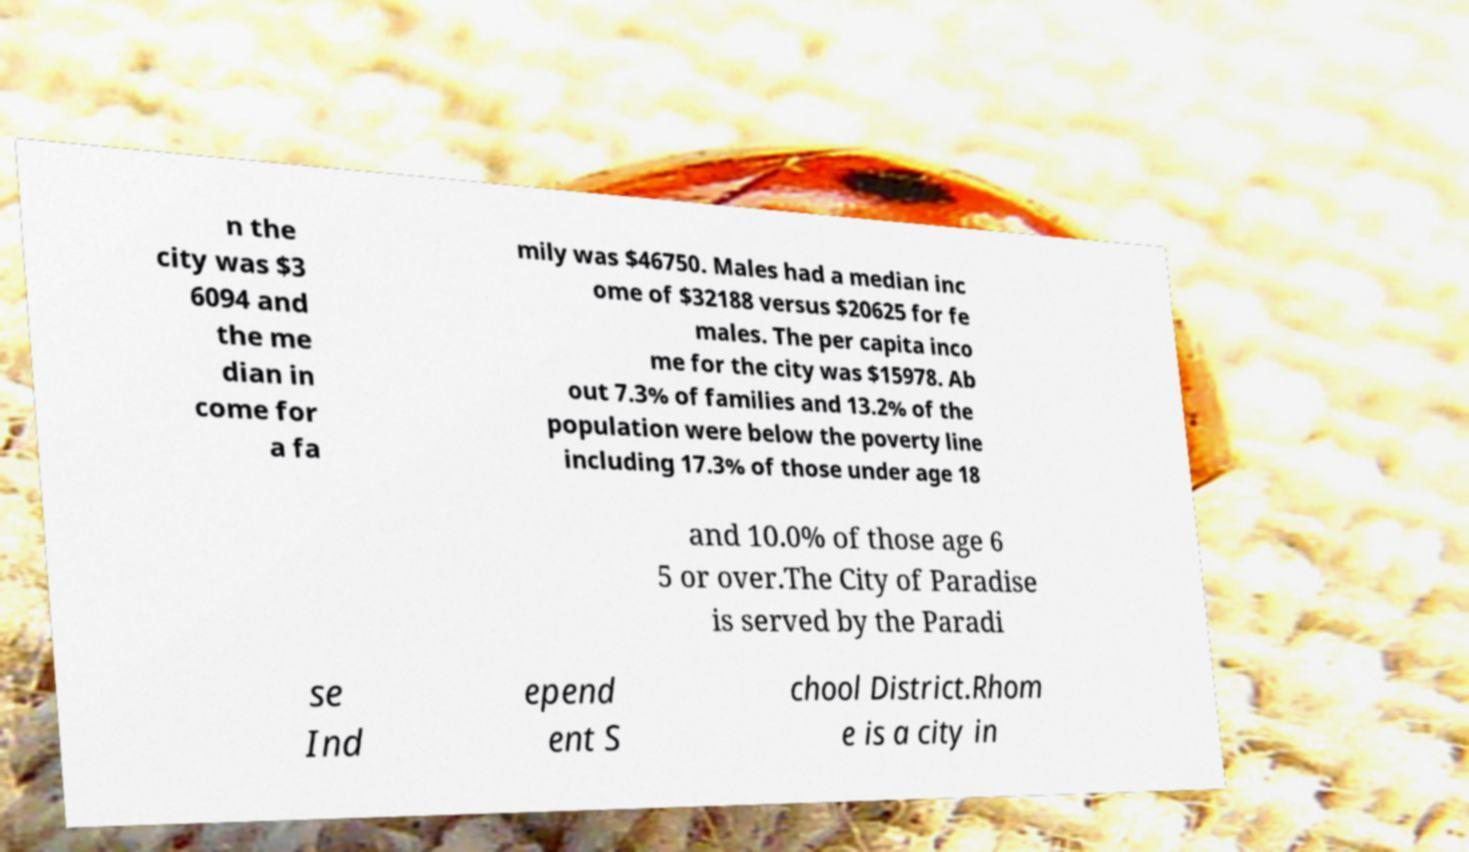Could you extract and type out the text from this image? n the city was $3 6094 and the me dian in come for a fa mily was $46750. Males had a median inc ome of $32188 versus $20625 for fe males. The per capita inco me for the city was $15978. Ab out 7.3% of families and 13.2% of the population were below the poverty line including 17.3% of those under age 18 and 10.0% of those age 6 5 or over.The City of Paradise is served by the Paradi se Ind epend ent S chool District.Rhom e is a city in 